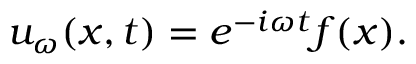<formula> <loc_0><loc_0><loc_500><loc_500>u _ { \omega } ( x , t ) = e ^ { - i \omega t } f ( x ) .</formula> 